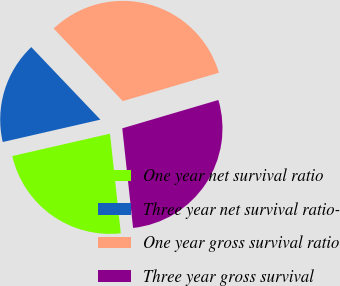Convert chart to OTSL. <chart><loc_0><loc_0><loc_500><loc_500><pie_chart><fcel>One year net survival ratio<fcel>Three year net survival ratio-<fcel>One year gross survival ratio<fcel>Three year gross survival<nl><fcel>23.14%<fcel>16.47%<fcel>32.55%<fcel>27.84%<nl></chart> 